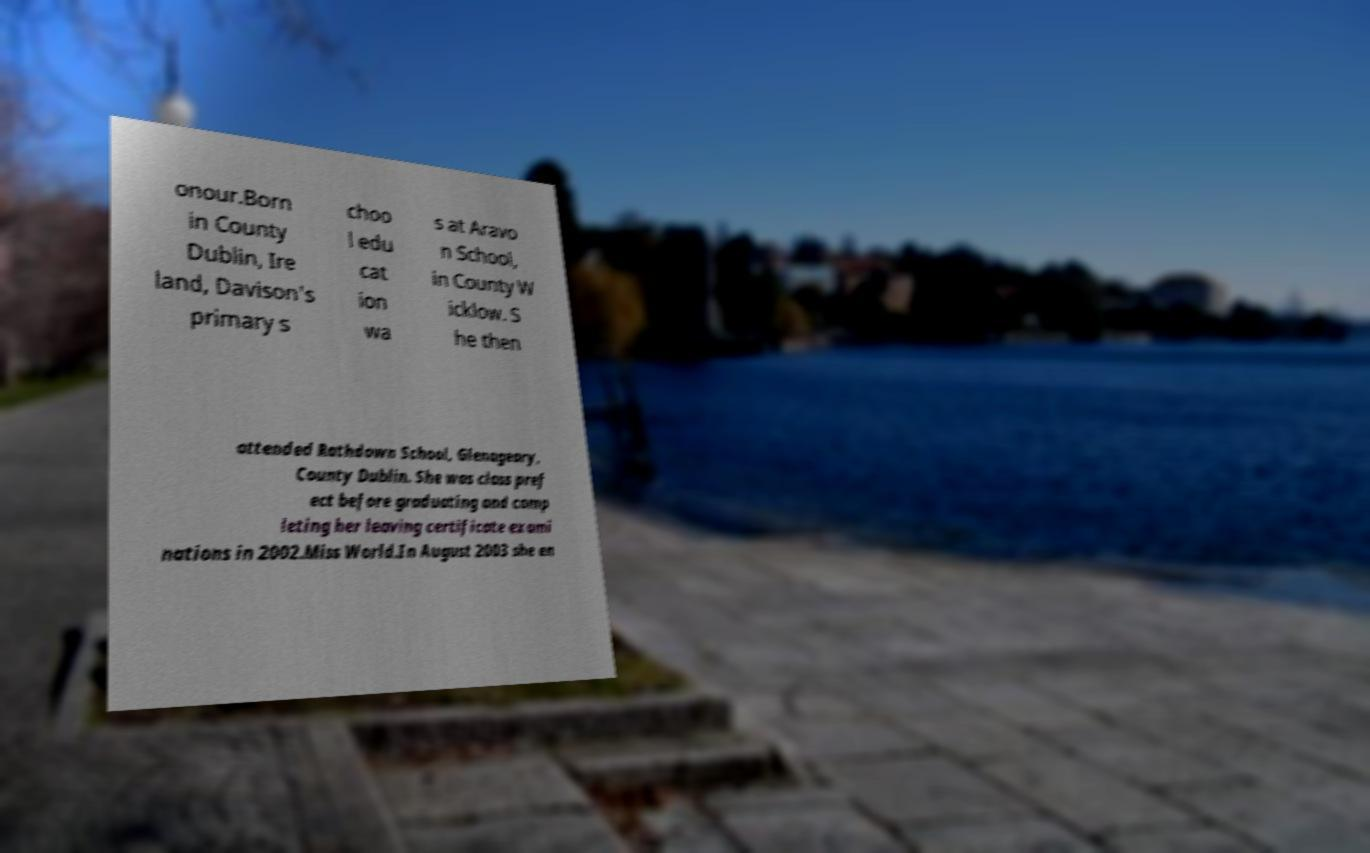Could you extract and type out the text from this image? onour.Born in County Dublin, Ire land, Davison's primary s choo l edu cat ion wa s at Aravo n School, in County W icklow. S he then attended Rathdown School, Glenageary, County Dublin. She was class pref ect before graduating and comp leting her leaving certificate exami nations in 2002.Miss World.In August 2003 she en 